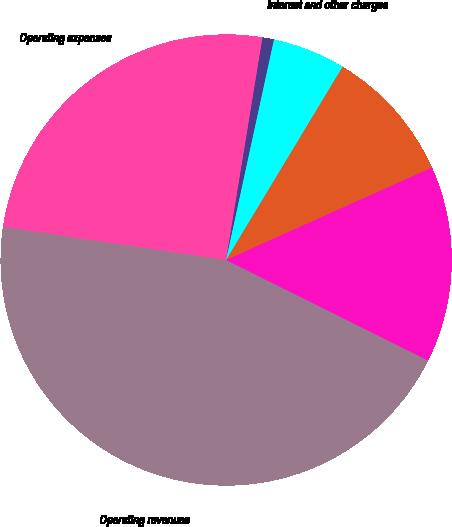Convert chart. <chart><loc_0><loc_0><loc_500><loc_500><pie_chart><fcel>Operating revenues<fcel>Operating expenses<fcel>Other income<fcel>Interest and other charges<fcel>Income taxes<fcel>Net income<nl><fcel>45.0%<fcel>25.23%<fcel>0.82%<fcel>5.23%<fcel>9.65%<fcel>14.07%<nl></chart> 